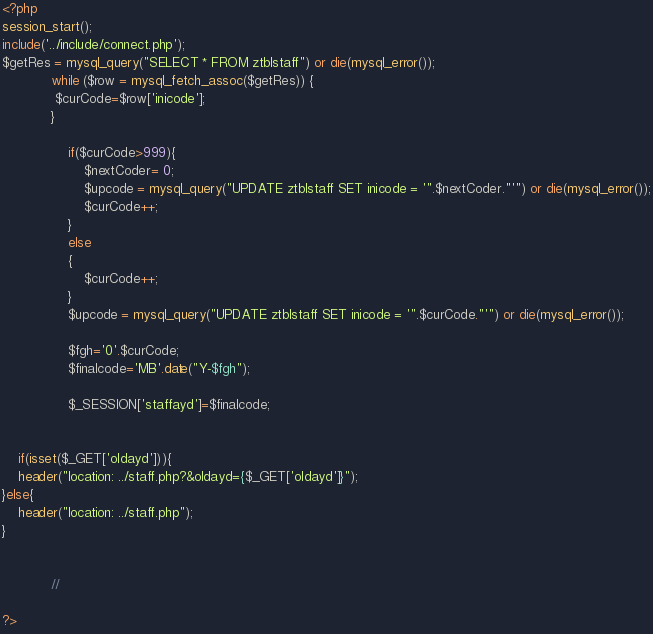<code> <loc_0><loc_0><loc_500><loc_500><_PHP_>
<?php
session_start();
include('../include/connect.php');
$getRes = mysql_query("SELECT * FROM ztblstaff") or die(mysql_error());
			while ($row = mysql_fetch_assoc($getRes)) {
			 $curCode=$row['inicode'];
			}

				if($curCode>999){
					$nextCoder= 0;
					$upcode = mysql_query("UPDATE ztblstaff SET inicode = '".$nextCoder."'") or die(mysql_error());
					$curCode++;
				}
  				else
				{
					$curCode++;
				}
				$upcode = mysql_query("UPDATE ztblstaff SET inicode = '".$curCode."'") or die(mysql_error());

				$fgh='0'.$curCode;
				$finalcode='MB'.date("Y-$fgh");
		
				$_SESSION['staffayd']=$finalcode;


	if(isset($_GET['oldayd'])){
	header("location: ../staff.php?&oldayd={$_GET['oldayd']}");
}else{	
	header("location: ../staff.php");
}

		
			//

?></code> 